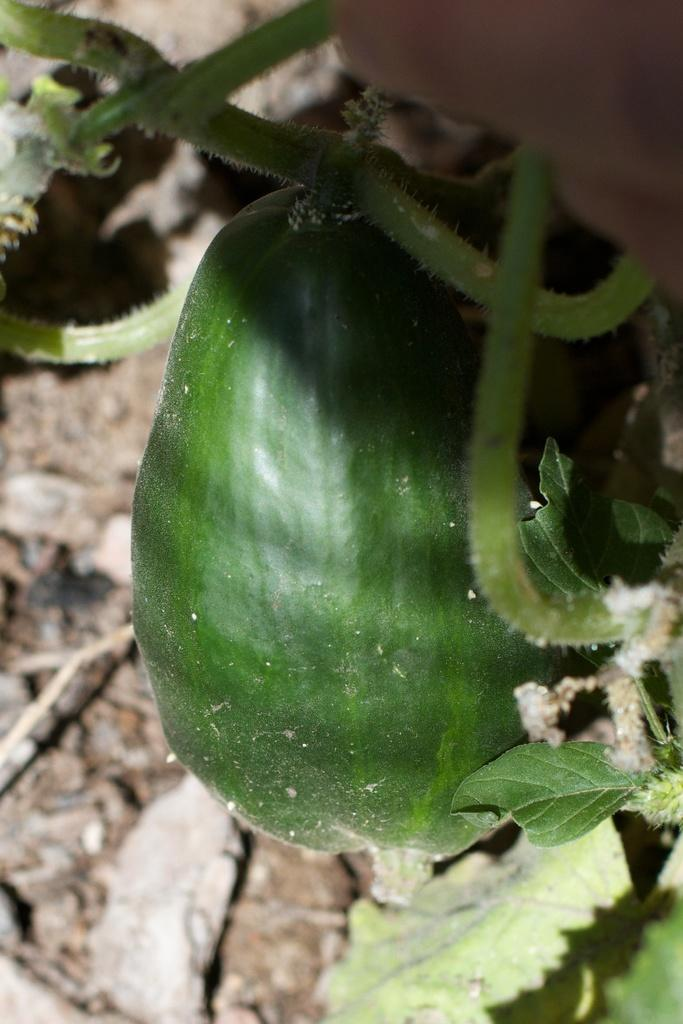What color are the vegetables in the image? The vegetables in the image are green-colored. What else in the image shares the same green color? There are green-colored leaves in the image. What type of pot is visible in the image? There is no pot present in the image. What can be seen between the teeth in the image? There are no teeth present in the image. 